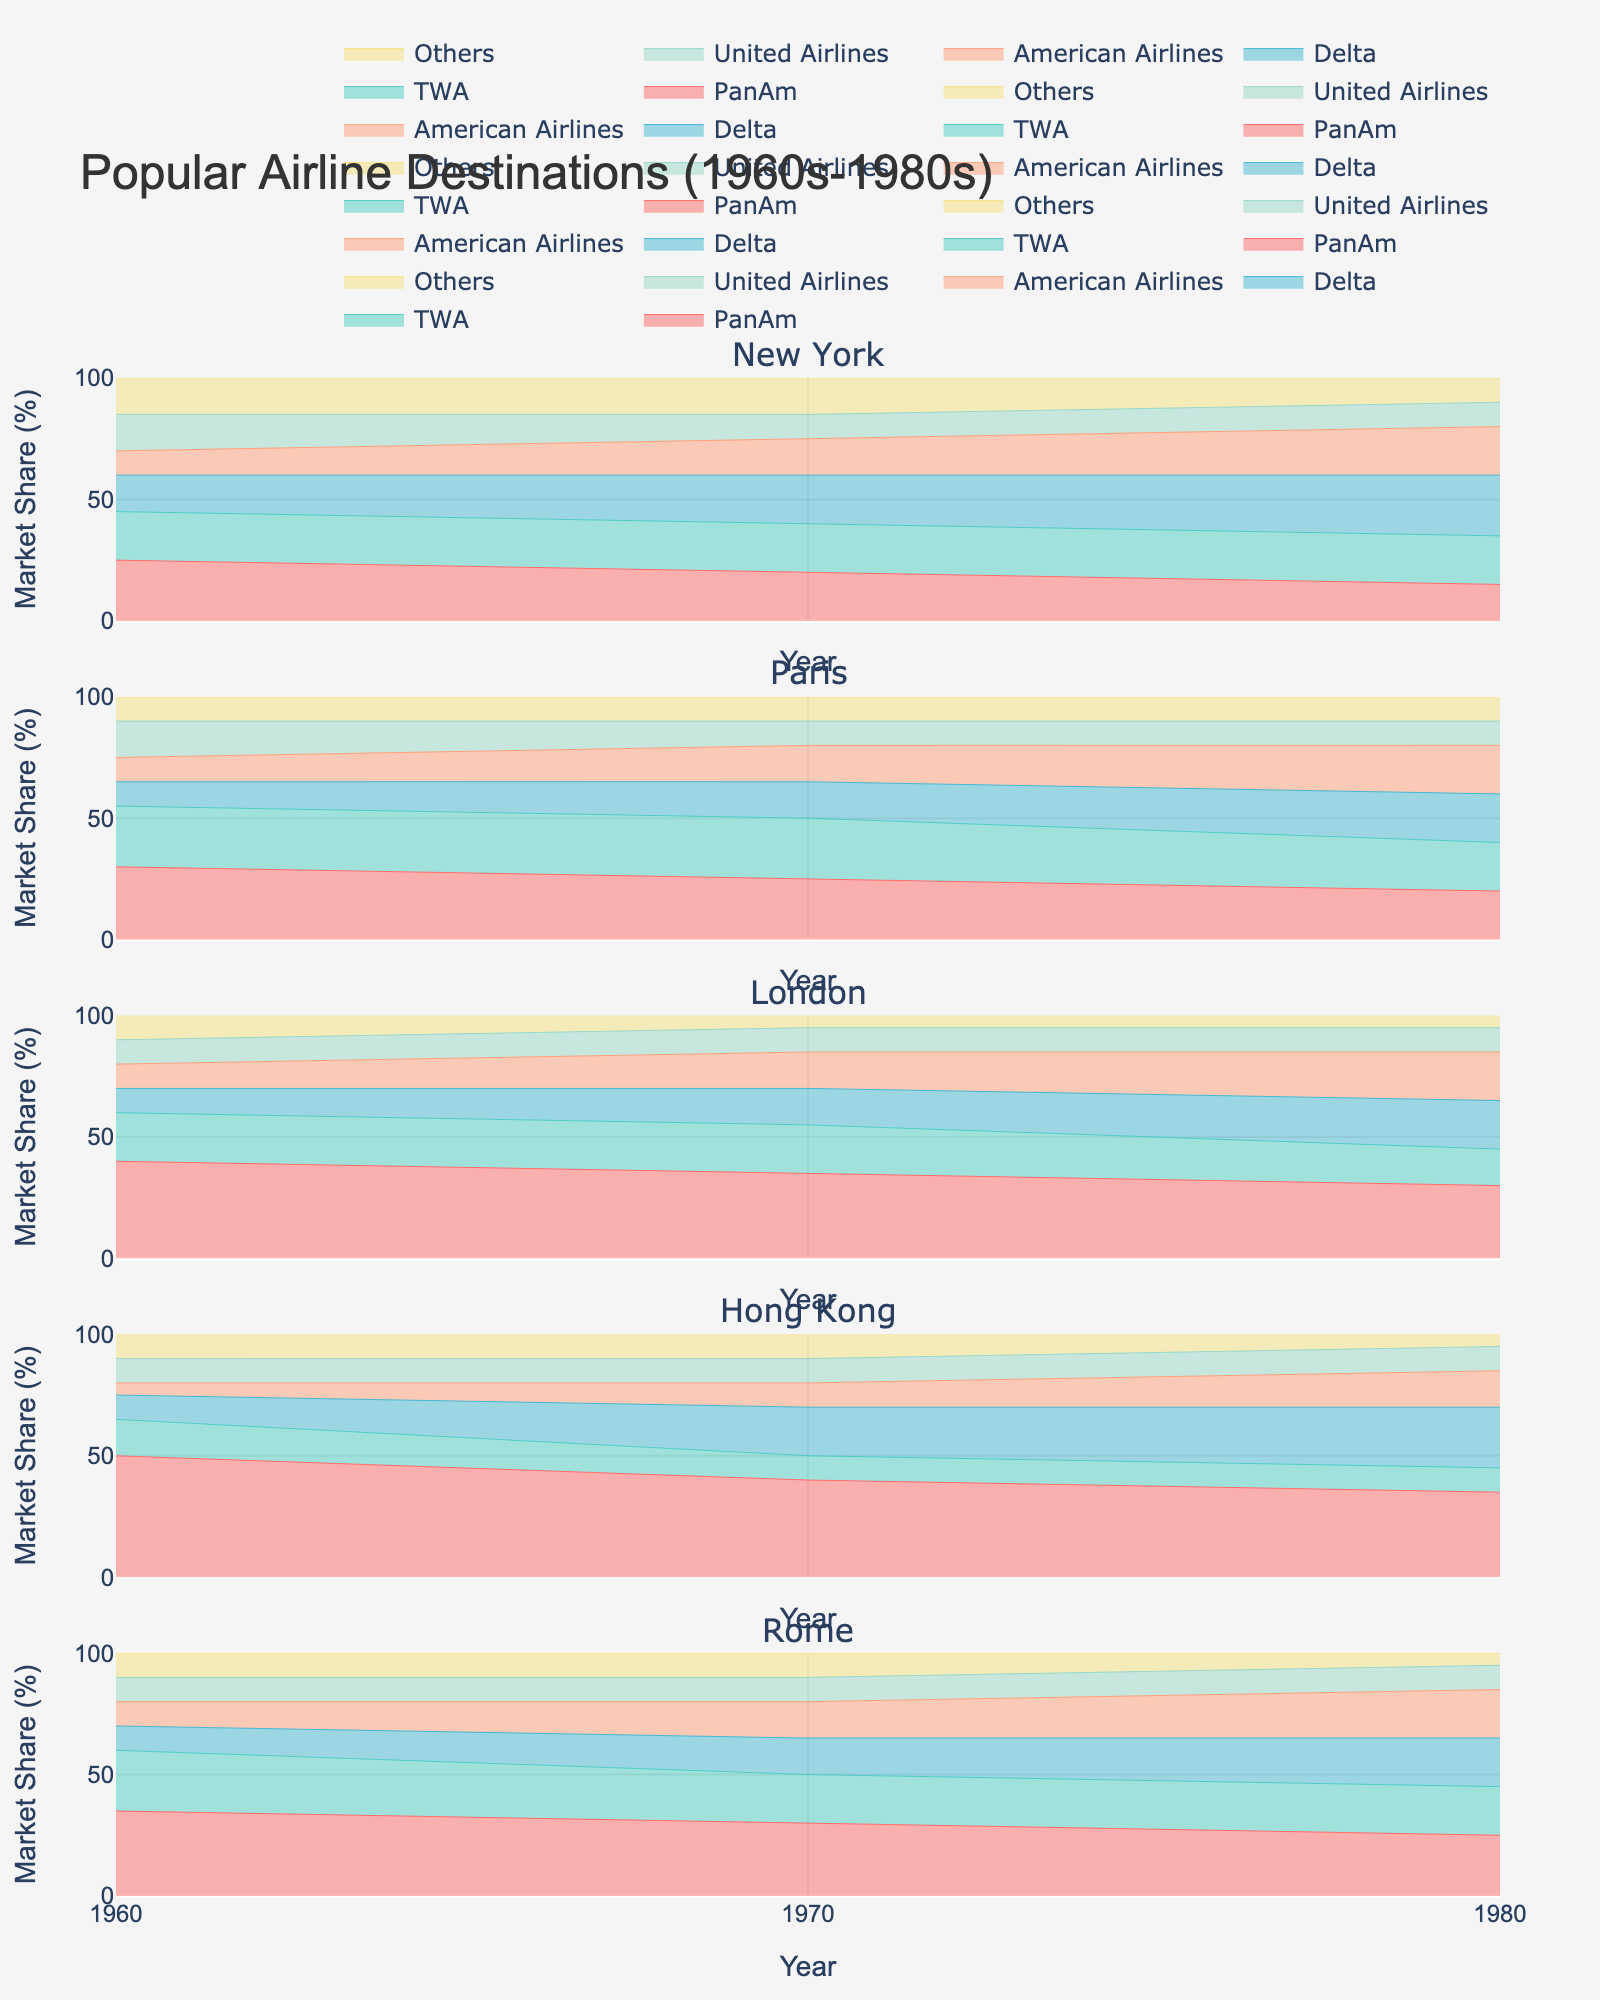What is the title of the chart? The title of the chart is displayed prominently at the top of the figure.
Answer: Popular Airline Destinations (1960s-1980s) What does the y-axis represent? The y-axis is labeled with "Market Share (%)", indicating that it represents the percentage market share of the carriers.
Answer: Market Share (%) How many destinations are displayed in the figure? The figure has subplots for each destination, and the subplot titles list all the destinations.
Answer: 5 Which carrier had the highest market share for flights to New York in 1960? Looking at the New York subplot for 1960, the largest segment is at the bottom of the stack, which corresponds to PanAm with 25%.
Answer: PanAm Did any carrier have a growing market share for Paris from 1960 to 1980? By examining the Paris subplot and comparing the segments for each carrier across the years, we can see if any carrier's share increased over time. American Airlines shows an increase from 10% in 1960 to 20% in 1980.
Answer: American Airlines Which destination had the largest market share for Delta in 1980? By comparing the relative sizes of Delta's segments in the 1980 subplot of each destination, it's clear that Delta had the largest share for flights to New York, at 25%.
Answer: New York What is the average market share of PanAm across all destinations in 1970? The market shares of PanAm in 1970 for New York, Paris, London, Hong Kong, and Rome are (20, 25, 35, 40, 30). The average is (20 + 25 + 35 + 40 + 30)/5 = 150/5 = 30%.
Answer: 30% How did the market share for TWA change for flights to Rome from 1960 to 1980? The Rome subplot shows that TWA's market share started at 25% in 1960, dipped to 20% in 1970, and remained at 20% in 1980, indicating a decrease from 1960 to 1970 but stability from 1970 to 1980.
Answer: Decreased from 1960 to 1970, stable from 1970 to 1980 Which carrier consistently held a smaller market share for flights to Hong Kong across all years? By comparing the market share segments for each carrier in the Hong Kong subplot over the years, United Airlines consistently held a smaller market share (10% in all years).
Answer: United Airlines For flights to London, which two carriers had overlapping market shares in 1980? In the London subplot, the market shares for Delta and American Airlines each are about 20% in 1980, indicating overlap.
Answer: Delta and American Airlines 